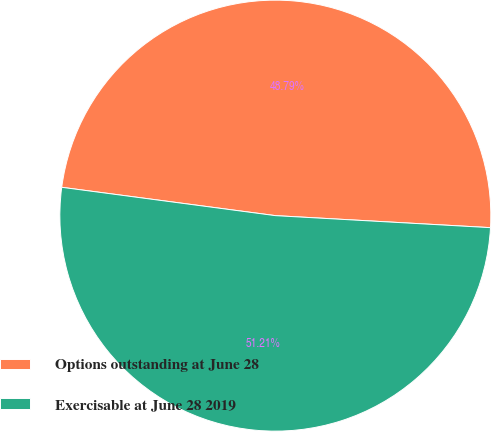<chart> <loc_0><loc_0><loc_500><loc_500><pie_chart><fcel>Options outstanding at June 28<fcel>Exercisable at June 28 2019<nl><fcel>48.79%<fcel>51.21%<nl></chart> 